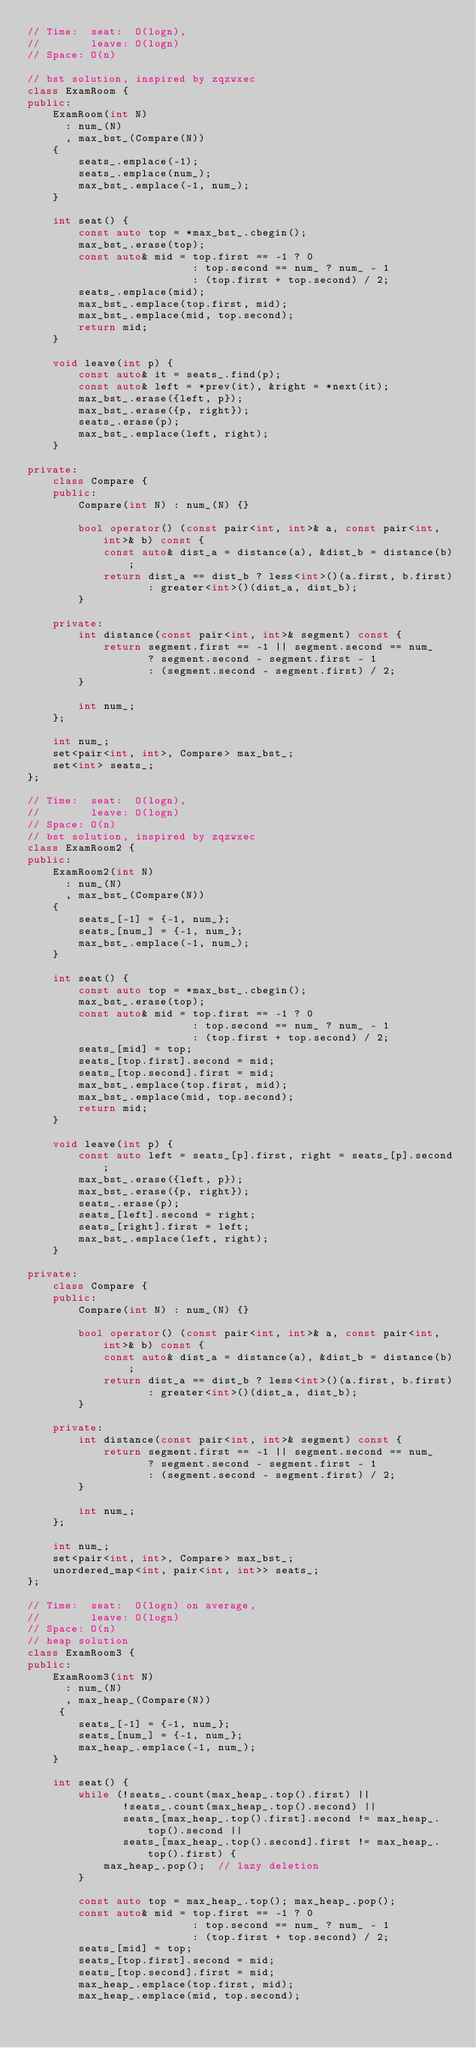Convert code to text. <code><loc_0><loc_0><loc_500><loc_500><_C++_>// Time:  seat:  O(logn),
//        leave: O(logn)
// Space: O(n)

// bst solution, inspired by zqzwxec
class ExamRoom {
public:
    ExamRoom(int N)
      : num_(N)
      , max_bst_(Compare(N))
    {
        seats_.emplace(-1);
        seats_.emplace(num_);
        max_bst_.emplace(-1, num_);
    }
    
    int seat() {
        const auto top = *max_bst_.cbegin();
        max_bst_.erase(top);
        const auto& mid = top.first == -1 ? 0
                          : top.second == num_ ? num_ - 1
                          : (top.first + top.second) / 2;
        seats_.emplace(mid);
        max_bst_.emplace(top.first, mid);
        max_bst_.emplace(mid, top.second);
        return mid;
    }
    
    void leave(int p) {
        const auto& it = seats_.find(p);
        const auto& left = *prev(it), &right = *next(it);
        max_bst_.erase({left, p});
        max_bst_.erase({p, right});
        seats_.erase(p);
        max_bst_.emplace(left, right);
    }

private:
    class Compare {
    public:
        Compare(int N) : num_(N) {}

        bool operator() (const pair<int, int>& a, const pair<int, int>& b) const {
            const auto& dist_a = distance(a), &dist_b = distance(b);
            return dist_a == dist_b ? less<int>()(a.first, b.first)
                   : greater<int>()(dist_a, dist_b);
        }
    
    private:
        int distance(const pair<int, int>& segment) const {
            return segment.first == -1 || segment.second == num_
                   ? segment.second - segment.first - 1
                   : (segment.second - segment.first) / 2;
        }

        int num_;
    };
    
    int num_;
    set<pair<int, int>, Compare> max_bst_;
    set<int> seats_;
};

// Time:  seat:  O(logn),
//        leave: O(logn)
// Space: O(n)
// bst solution, inspired by zqzwxec
class ExamRoom2 {
public:
    ExamRoom2(int N)
      : num_(N)
      , max_bst_(Compare(N))
    {
        seats_[-1] = {-1, num_};
        seats_[num_] = {-1, num_};
        max_bst_.emplace(-1, num_);
    }
    
    int seat() {
        const auto top = *max_bst_.cbegin();
        max_bst_.erase(top);
        const auto& mid = top.first == -1 ? 0
                          : top.second == num_ ? num_ - 1
                          : (top.first + top.second) / 2;
        seats_[mid] = top;
        seats_[top.first].second = mid;
        seats_[top.second].first = mid;
        max_bst_.emplace(top.first, mid);
        max_bst_.emplace(mid, top.second);
        return mid;
    }
    
    void leave(int p) {
        const auto left = seats_[p].first, right = seats_[p].second;
        max_bst_.erase({left, p});
        max_bst_.erase({p, right});
        seats_.erase(p);
        seats_[left].second = right;
        seats_[right].first = left;
        max_bst_.emplace(left, right);
    }

private:
    class Compare {
    public:
        Compare(int N) : num_(N) {}

        bool operator() (const pair<int, int>& a, const pair<int, int>& b) const {
            const auto& dist_a = distance(a), &dist_b = distance(b);
            return dist_a == dist_b ? less<int>()(a.first, b.first)
                   : greater<int>()(dist_a, dist_b);
        }
    
    private:
        int distance(const pair<int, int>& segment) const {
            return segment.first == -1 || segment.second == num_
                   ? segment.second - segment.first - 1
                   : (segment.second - segment.first) / 2;
        }

        int num_;
    };
    
    int num_;
    set<pair<int, int>, Compare> max_bst_;
    unordered_map<int, pair<int, int>> seats_;
};

// Time:  seat:  O(logn) on average,
//        leave: O(logn)
// Space: O(n)
// heap solution
class ExamRoom3 {
public:
    ExamRoom3(int N)
      : num_(N)
      , max_heap_(Compare(N))
     {
        seats_[-1] = {-1, num_};
        seats_[num_] = {-1, num_};
        max_heap_.emplace(-1, num_);
    }
    
    int seat() {
        while (!seats_.count(max_heap_.top().first) ||
               !seats_.count(max_heap_.top().second) ||
               seats_[max_heap_.top().first].second != max_heap_.top().second ||
               seats_[max_heap_.top().second].first != max_heap_.top().first) {
            max_heap_.pop();  // lazy deletion
        }
        
        const auto top = max_heap_.top(); max_heap_.pop();
        const auto& mid = top.first == -1 ? 0
                          : top.second == num_ ? num_ - 1
                          : (top.first + top.second) / 2;
        seats_[mid] = top;
        seats_[top.first].second = mid;
        seats_[top.second].first = mid;
        max_heap_.emplace(top.first, mid);
        max_heap_.emplace(mid, top.second);</code> 